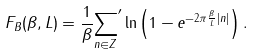<formula> <loc_0><loc_0><loc_500><loc_500>F _ { B } ( \beta , L ) = \frac { 1 } { \beta } { \sum _ { n \in { Z } } } ^ { \prime } \ln { \left ( 1 - e ^ { - 2 \pi \frac { \beta } { L } | n | } \right ) } \, .</formula> 